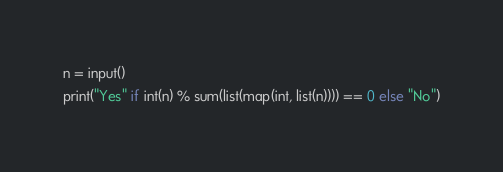<code> <loc_0><loc_0><loc_500><loc_500><_Python_>n = input()
print("Yes" if int(n) % sum(list(map(int, list(n)))) == 0 else "No")</code> 